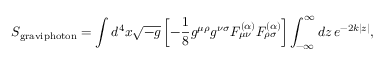Convert formula to latex. <formula><loc_0><loc_0><loc_500><loc_500>S _ { g r a v i p h o t o n } = \int d ^ { 4 } x \sqrt { - g } \left [ - \frac { 1 } { 8 } g ^ { \mu \rho } g ^ { \nu \sigma } F _ { \mu \nu } ^ { ( \alpha ) } F _ { \rho \sigma } ^ { ( \alpha ) } \right ] \int _ { - \infty } ^ { \infty } d z \, e ^ { - 2 k | z | } ,</formula> 